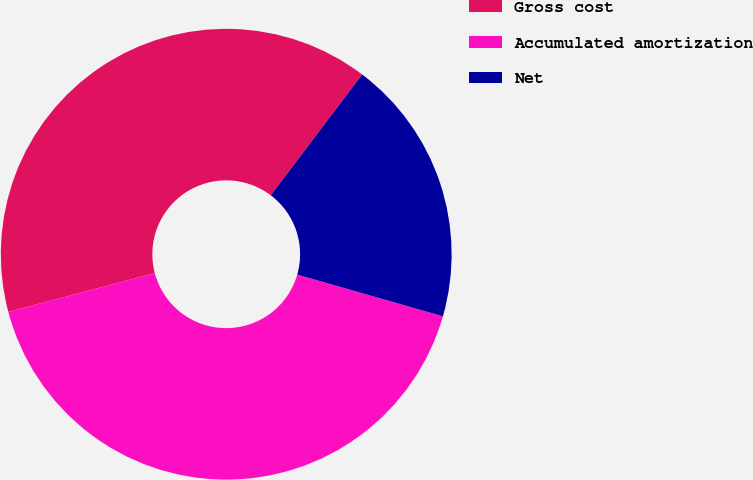<chart> <loc_0><loc_0><loc_500><loc_500><pie_chart><fcel>Gross cost<fcel>Accumulated amortization<fcel>Net<nl><fcel>39.42%<fcel>41.44%<fcel>19.14%<nl></chart> 